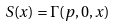Convert formula to latex. <formula><loc_0><loc_0><loc_500><loc_500>S ( x ) = \Gamma ( p , 0 , x )</formula> 